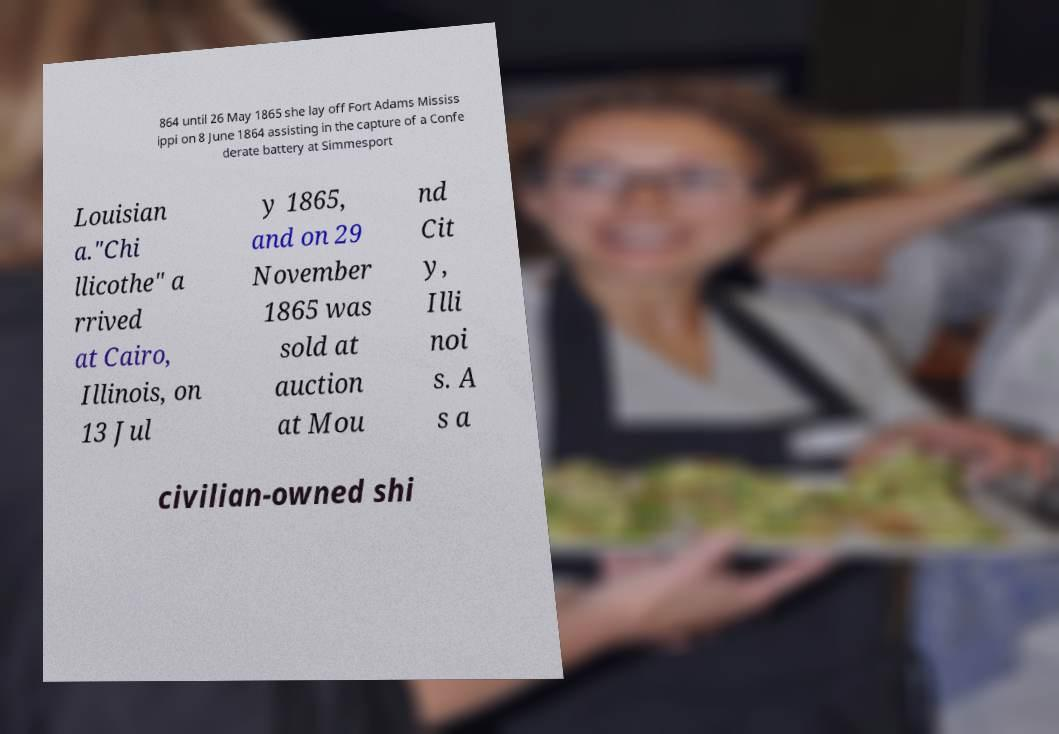For documentation purposes, I need the text within this image transcribed. Could you provide that? 864 until 26 May 1865 she lay off Fort Adams Mississ ippi on 8 June 1864 assisting in the capture of a Confe derate battery at Simmesport Louisian a."Chi llicothe" a rrived at Cairo, Illinois, on 13 Jul y 1865, and on 29 November 1865 was sold at auction at Mou nd Cit y, Illi noi s. A s a civilian-owned shi 